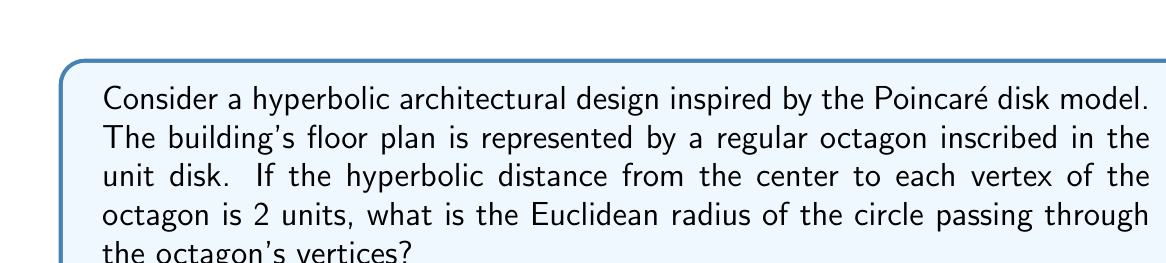Show me your answer to this math problem. Let's approach this step-by-step:

1) In the Poincaré disk model, the hyperbolic distance $d$ between two points $(0,0)$ and $(x,y)$ is given by:

   $$d = 2\tanh^{-1}\left(\sqrt{x^2+y^2}\right)$$

2) We're told that the hyperbolic distance from the center to each vertex is 2 units. Let's call the Euclidean radius we're looking for $r$. Then:

   $$2 = 2\tanh^{-1}(r)$$

3) Solving for $r$:

   $$1 = \tanh^{-1}(r)$$
   $$\tanh(1) = r$$

4) We can calculate this value:

   $$r = \tanh(1) \approx 0.7615941559557649$$

5) To verify the symmetry, we can visualize this in the Poincaré disk model:

[asy]
import geometry;

unitcircle();
real r = tanh(1);
for(int i=0; i<8; ++i) {
  dot(r*dir(i*45));
}
draw(circle((0,0),r));
[/asy]

This diagram shows the octagon inscribed in the unit disk, with vertices lying on a circle of radius $r$.

6) The symmetry of this design in hyperbolic space is preserved, as all vertices are equidistant from the center in hyperbolic metric, despite appearing closer to the edge in Euclidean space.
Answer: $\tanh(1) \approx 0.7616$ 